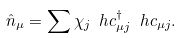<formula> <loc_0><loc_0><loc_500><loc_500>\hat { n } _ { \mu } = \sum \chi _ { j } \ h c ^ { \dag } _ { \mu j } \ h c _ { \mu j } .</formula> 